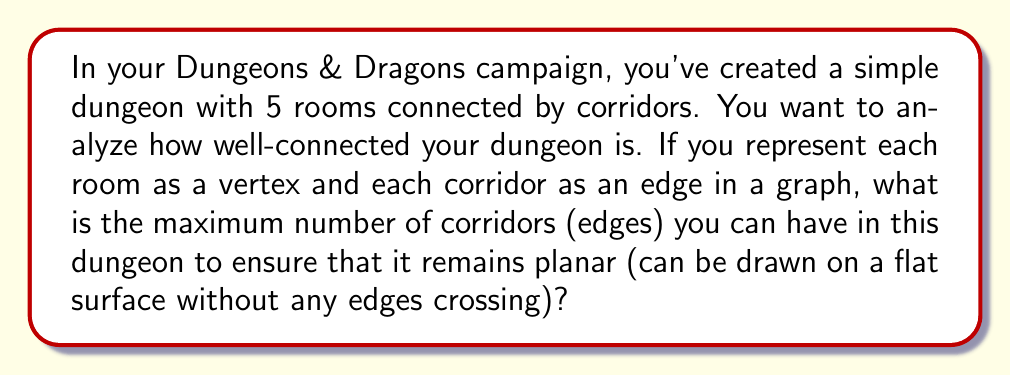Solve this math problem. Let's approach this step-by-step using some basic graph theory:

1) First, recall that in a planar graph with $n$ vertices, the maximum number of edges is given by the formula:

   $$e_{max} = 3n - 6$$

   where $e_{max}$ is the maximum number of edges and $n$ is the number of vertices.

2) In this case, we have 5 rooms, so $n = 5$.

3) Let's substitute this into our formula:

   $$e_{max} = 3(5) - 6$$

4) Now we can solve:

   $$e_{max} = 15 - 6 = 9$$

5) Therefore, the maximum number of corridors (edges) we can have while keeping the dungeon map planar is 9.

This result means that with 5 rooms, you can have up to 9 corridors connecting them in various ways, and still be able to draw your dungeon map on a flat piece of paper without any corridors crossing each other.

In D&D terms, this allows for a fairly complex dungeon layout while still keeping the map easy to draw and understand for new players.
Answer: The maximum number of corridors (edges) is 9. 